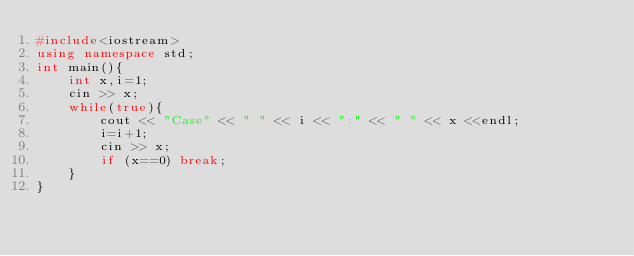Convert code to text. <code><loc_0><loc_0><loc_500><loc_500><_C++_>#include<iostream>
using namespace std;
int main(){
    int x,i=1;
    cin >> x;
    while(true){
        cout << "Case" << " " << i << ":" << " " << x <<endl;
        i=i+1;
        cin >> x;
        if (x==0) break;
    }
}
</code> 